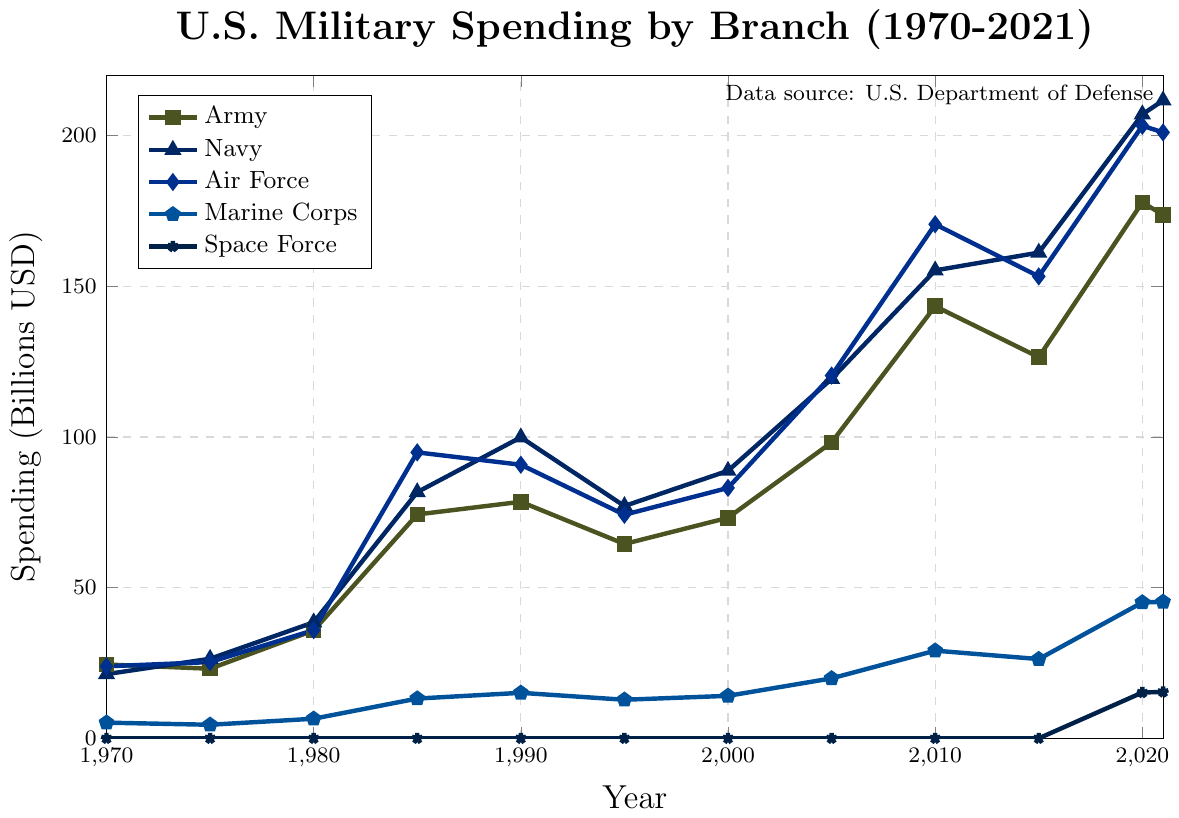what was the total military spending for all branches in 1985? Add the 1985 spending amounts for Army (74.3), Navy (81.7), Air Force (94.9), and Marine Corps (13.2): 74.3 + 81.7 + 94.9 + 13.2 = 264.1 billion USD
Answer: 264.1 Which branch received the highest funding in 2020? In 2020, the Navy had the highest spending at 207.1 billion USD, followed by the Air Force (203.3), Army (177.9), Marine Corps (45.1), and Space Force (15.2)
Answer: Navy By how much did Army spending increase from 1975 to 2020? Army spending in 1975 was 23.1 billion USD, and in 2020 it was 177.9 billion USD. The increase is 177.9 - 23.1 = 154.8 billion USD
Answer: 154.8 Which branch had the smallest increase in spending between 1970 and 1990? Look at the difference in spending for each branch from 1970 to 1990 and compare: Army (78.5 - 24.5 = 54), Navy (99.9 - 21.3 = 78.6), Air Force (90.8 - 23.9 = 66.9), Marine Corps (15.1 - 5.2 = 9.9). The smallest increase is for Marine Corps
Answer: Marine Corps What was the average spending of the Air Force from 2015 to 2021? Spending over the years 2015 (153.3), 2020 (203.3), and 2021 (201.1) are summed: 153.3 + 203.3 + 201.1 = 557.7. There are 3 years, so the average is 557.7 / 3 = 185.9 billion USD
Answer: 185.9 Compare the funding of the Marine Corps in 1995 and 2015. By what percentage did it increase or decrease? Marine Corps spending in 1995 was 12.8 billion USD, and in 2015 it was 26.3 billion USD. The increase is 26.3 - 12.8 = 13.5 billion USD. To find the percentage increase: (13.5 / 12.8) * 100 ≈ 105.5%
Answer: 105.5% Which two branches had nearly equal spending in 2015, and what were their amounts? In 2015, Air Force spending was 153.3 billion USD and Navy spending was 161.2 billion USD. These values are close
Answer: Air Force and Navy, 153.3 billion and 161.2 billion USD From 2010 to 2020, which branch saw the largest absolute increase in spending? Calculate the increase for each branch from 2010 to 2020: Army (177.9 - 143.4 = 34.5), Navy (207.1 - 155.3 = 51.8), Air Force (203.3 - 170.6 = 32.7), Marine Corps (45.1 - 29.1 = 16). The largest increase is for Navy
Answer: Navy, 51.8 By how much did Navy spending exceed Air Force spending in 2005? In 2005, Navy spending was 119.3 billion USD and Air Force spending was 120.4 billion USD. The Navy did not exceed Air Force; instead, compare the exceedance: 120.4 - 119.3 = 1.1 billion USD
Answer: Air Force exceeded by 1.1 